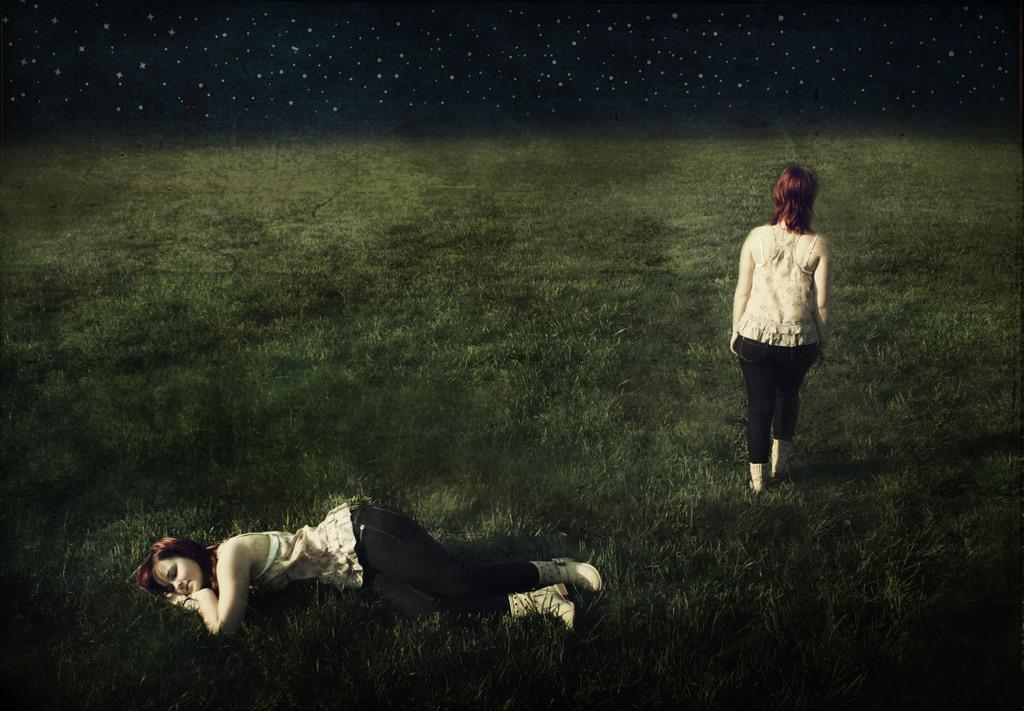What is the position of the woman in the image? There is a woman laying on the ground in the image, and another woman standing. What is the surface on which the women are situated? Grass is present on the ground in the image. What type of stamp can be seen on the woman's forehead in the image? There is no stamp present on the woman's forehead in the image. 